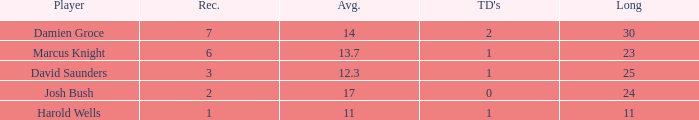How many touchdowns are there where the length is less than 23? 1.0. 